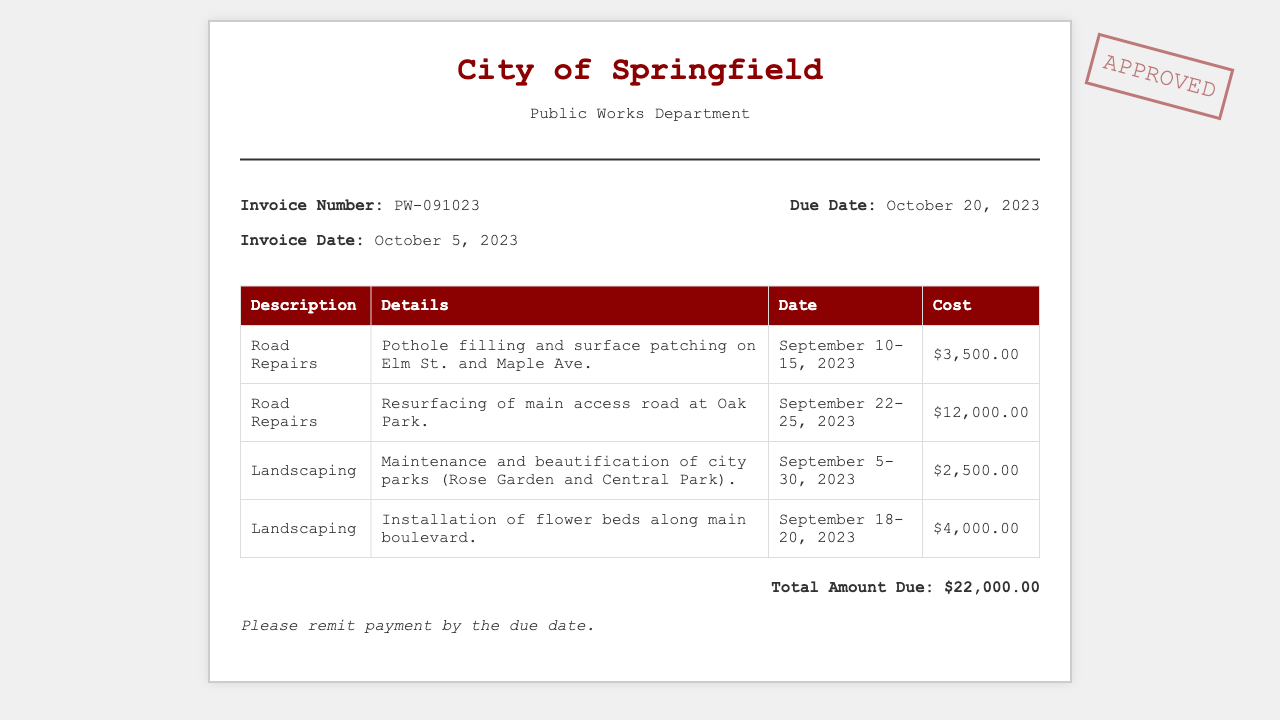what is the invoice number? The invoice number is stated as PW-091023 in the document.
Answer: PW-091023 what is the total amount due? The total amount due is clearly listed at the bottom of the invoice.
Answer: $22,000.00 how many road repair services are listed? There are two entries for road repairs in the services table of the document.
Answer: 2 what are the dates for the pothole filling and surface patching? The dates for the first road repair service are specified in the document.
Answer: September 10-15, 2023 what is the cost of landscaping services? The landscaping costs are summarized in the services table, detailing two landscaping entries.
Answer: $6,500.00 when is the due date for payment? The due date for payment is mentioned clearly in the invoice details.
Answer: October 20, 2023 what is the date of the invoice? The date the invoice was created is prominently displayed in the document.
Answer: October 5, 2023 what type of services are listed in the invoice? The services mentioned include road repairs and landscaping.
Answer: Road Repairs and Landscaping how many days does the landscaping maintenance cover? The period for landscaping maintenance is detailed in the invoice.
Answer: 26 days 